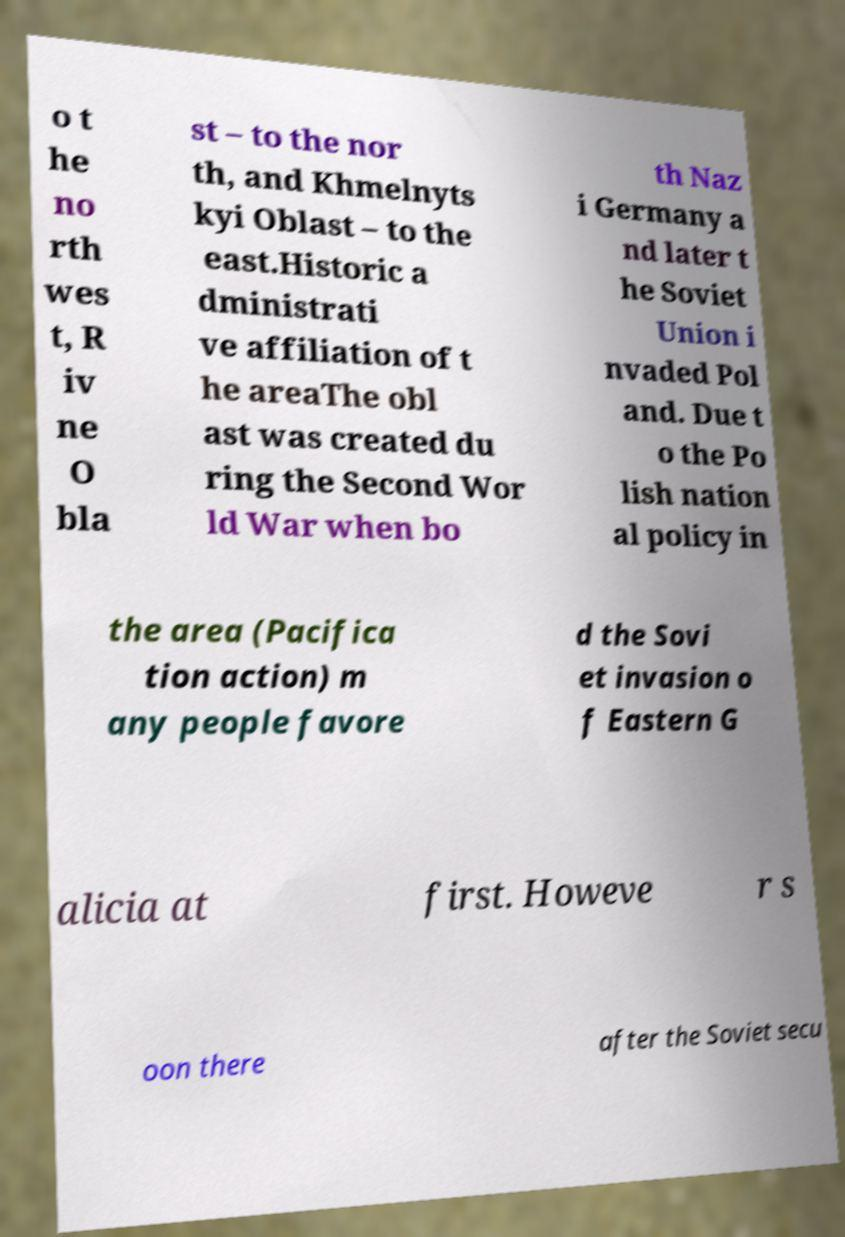Can you read and provide the text displayed in the image?This photo seems to have some interesting text. Can you extract and type it out for me? o t he no rth wes t, R iv ne O bla st – to the nor th, and Khmelnyts kyi Oblast – to the east.Historic a dministrati ve affiliation of t he areaThe obl ast was created du ring the Second Wor ld War when bo th Naz i Germany a nd later t he Soviet Union i nvaded Pol and. Due t o the Po lish nation al policy in the area (Pacifica tion action) m any people favore d the Sovi et invasion o f Eastern G alicia at first. Howeve r s oon there after the Soviet secu 